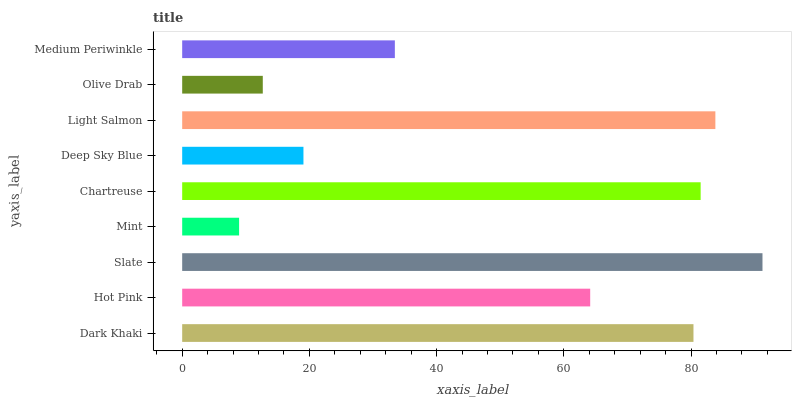Is Mint the minimum?
Answer yes or no. Yes. Is Slate the maximum?
Answer yes or no. Yes. Is Hot Pink the minimum?
Answer yes or no. No. Is Hot Pink the maximum?
Answer yes or no. No. Is Dark Khaki greater than Hot Pink?
Answer yes or no. Yes. Is Hot Pink less than Dark Khaki?
Answer yes or no. Yes. Is Hot Pink greater than Dark Khaki?
Answer yes or no. No. Is Dark Khaki less than Hot Pink?
Answer yes or no. No. Is Hot Pink the high median?
Answer yes or no. Yes. Is Hot Pink the low median?
Answer yes or no. Yes. Is Light Salmon the high median?
Answer yes or no. No. Is Medium Periwinkle the low median?
Answer yes or no. No. 